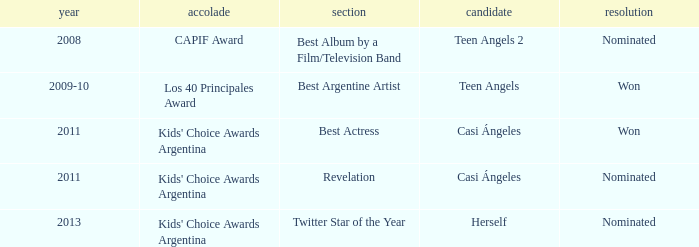For which prize was there a nomination for leading actress? Kids' Choice Awards Argentina. 